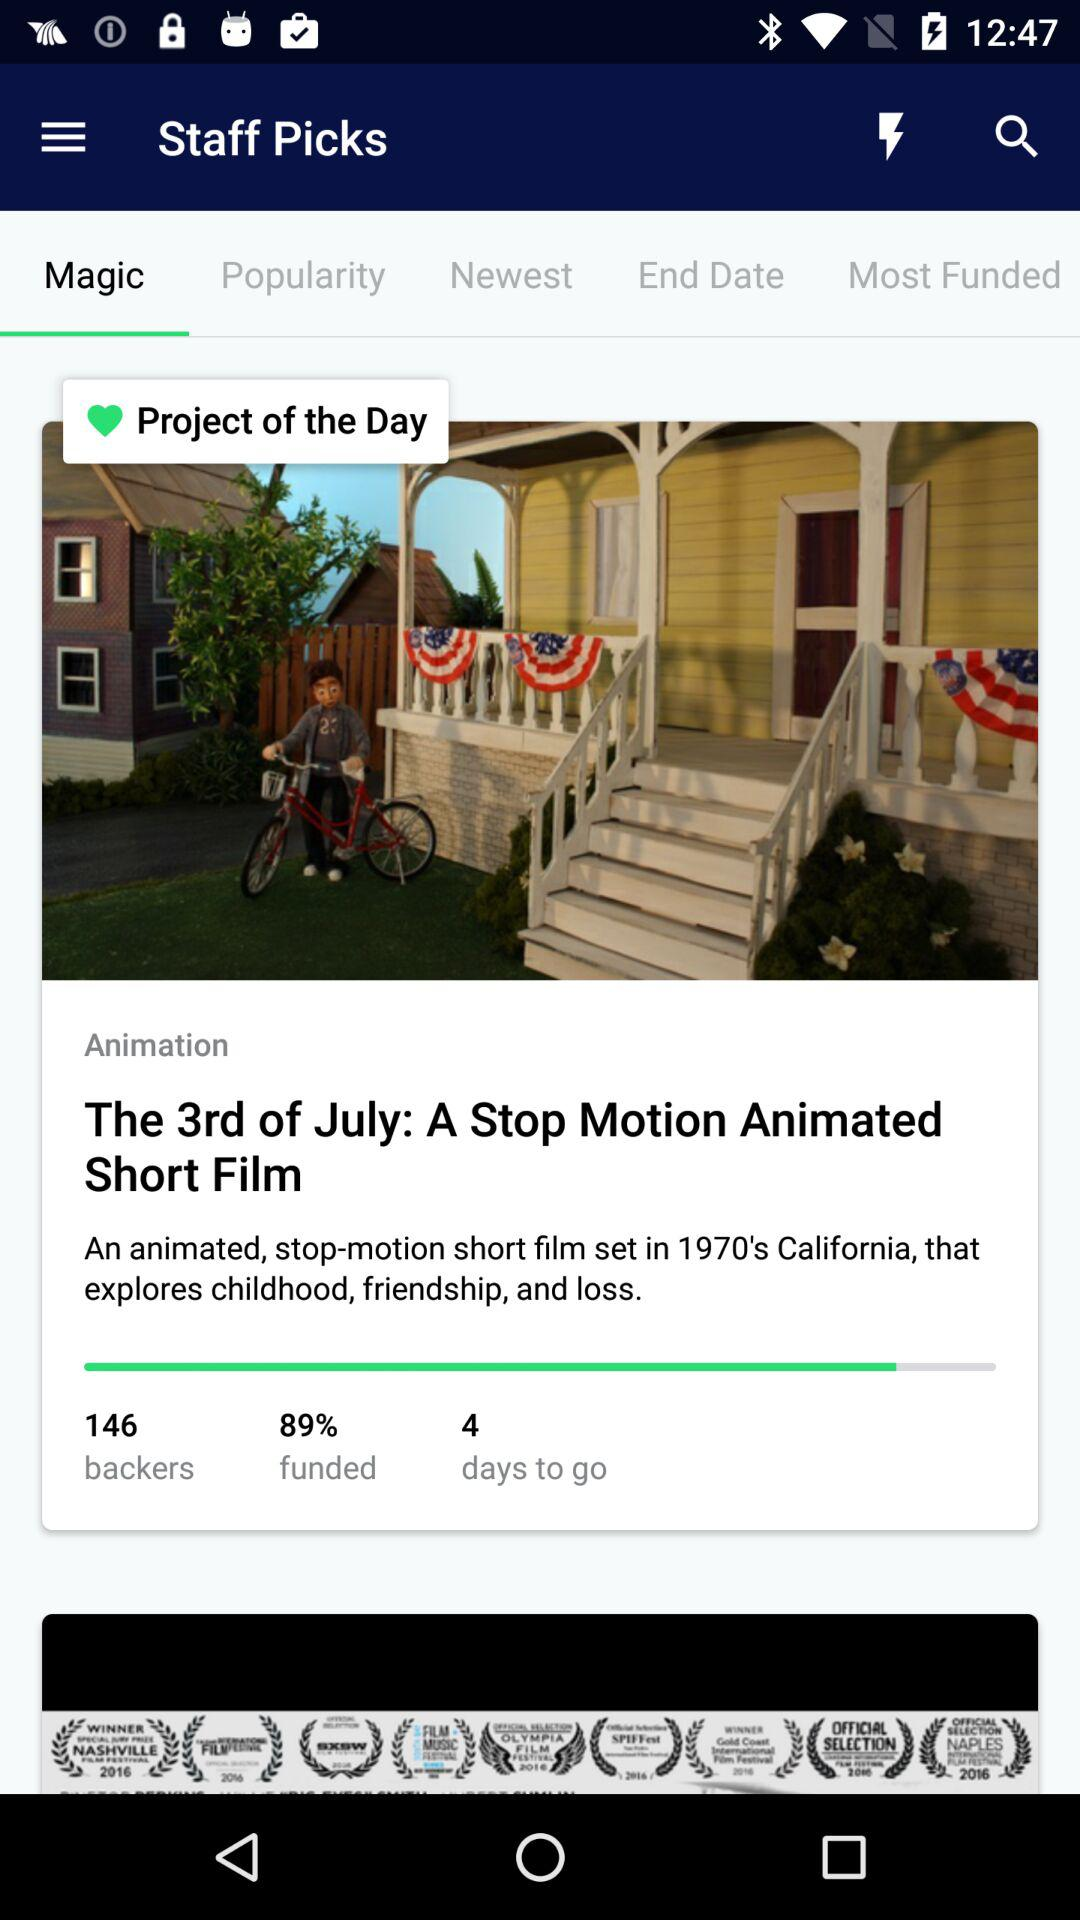How many backers does the project have?
Answer the question using a single word or phrase. 146 